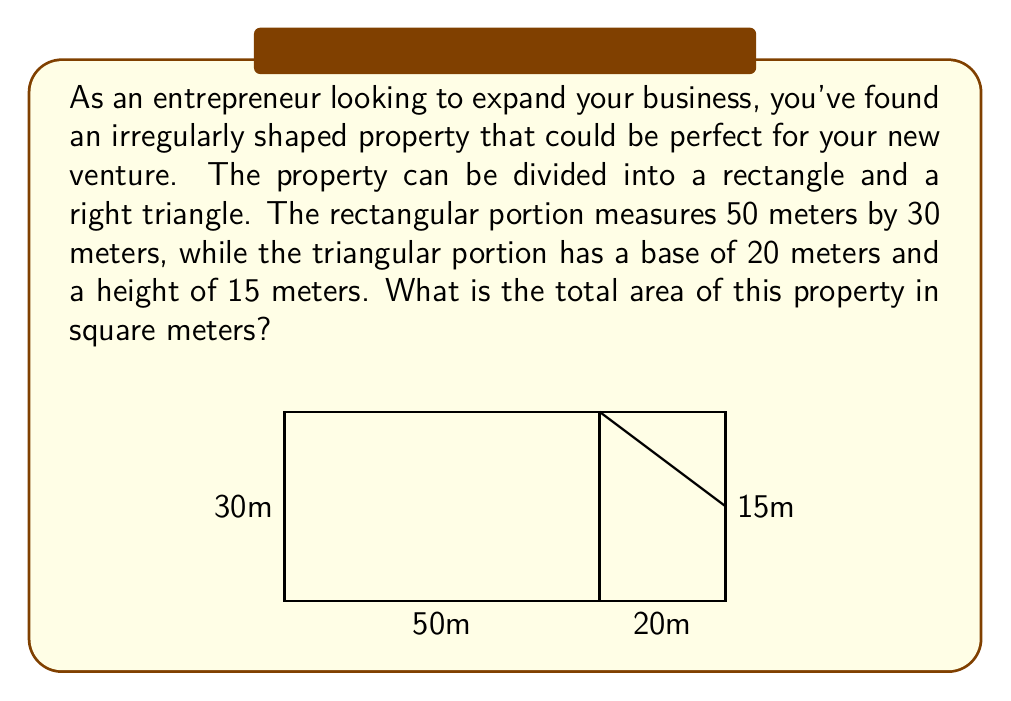Show me your answer to this math problem. To find the total area of the irregularly shaped property, we need to calculate the areas of the rectangular portion and the triangular portion separately, then add them together.

1. Area of the rectangular portion:
   $$ A_r = l \times w $$
   where $l$ is length and $w$ is width
   $$ A_r = 50 \text{ m} \times 30 \text{ m} = 1500 \text{ m}^2 $$

2. Area of the triangular portion:
   $$ A_t = \frac{1}{2} \times b \times h $$
   where $b$ is base and $h$ is height
   $$ A_t = \frac{1}{2} \times 20 \text{ m} \times 15 \text{ m} = 150 \text{ m}^2 $$

3. Total area of the property:
   $$ A_{\text{total}} = A_r + A_t $$
   $$ A_{\text{total}} = 1500 \text{ m}^2 + 150 \text{ m}^2 = 1650 \text{ m}^2 $$

Therefore, the total area of the irregularly shaped property is 1650 square meters.
Answer: 1650 m² 